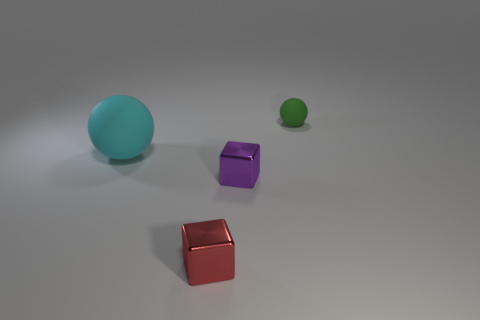There is a matte ball behind the large cyan matte thing; what color is it?
Make the answer very short. Green. There is a red metallic object that is the same size as the green sphere; what shape is it?
Ensure brevity in your answer.  Cube. What number of objects are cubes in front of the tiny purple object or spheres that are to the left of the red metallic block?
Provide a short and direct response. 2. There is a purple thing that is the same size as the green thing; what is its material?
Provide a short and direct response. Metal. What number of other things are there of the same material as the purple object
Your answer should be compact. 1. There is a thing left of the red metal object; does it have the same shape as the green thing to the right of the red metal block?
Your answer should be very brief. Yes. The matte object left of the matte thing that is to the right of the matte ball left of the red cube is what color?
Keep it short and to the point. Cyan. Are there fewer red metallic blocks than cyan rubber blocks?
Ensure brevity in your answer.  No. There is a object that is on the right side of the cyan rubber ball and behind the small purple cube; what color is it?
Provide a short and direct response. Green. What material is the other thing that is the same shape as the tiny red thing?
Offer a terse response. Metal. 